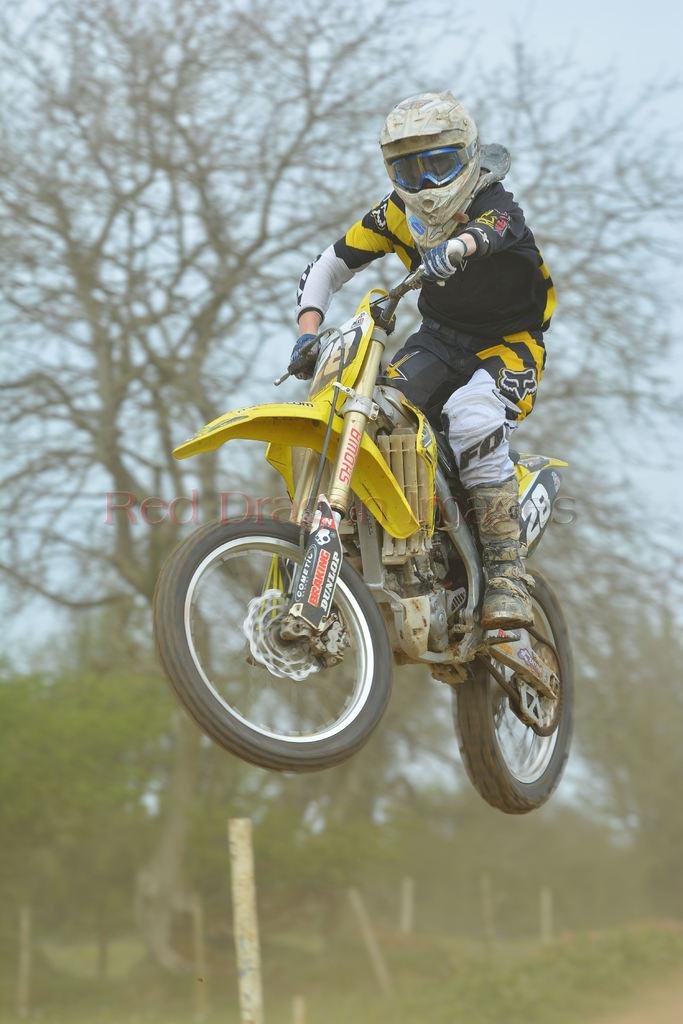What is happening in the image involving a person? The person is jumping with a motorbike. What can be seen in the background of the image? There are plants, trees, and the sky visible in the background of the image. Is there any indication of the image's origin or ownership? Yes, there is a watermark on the image. What type of nail is being used to hold the lumber together in the image? There is no nail or lumber present in the image; it features a person jumping with a motorbike and a background with plants, trees, and the sky. How many crows can be seen in the image? There are no crows present in the image. 